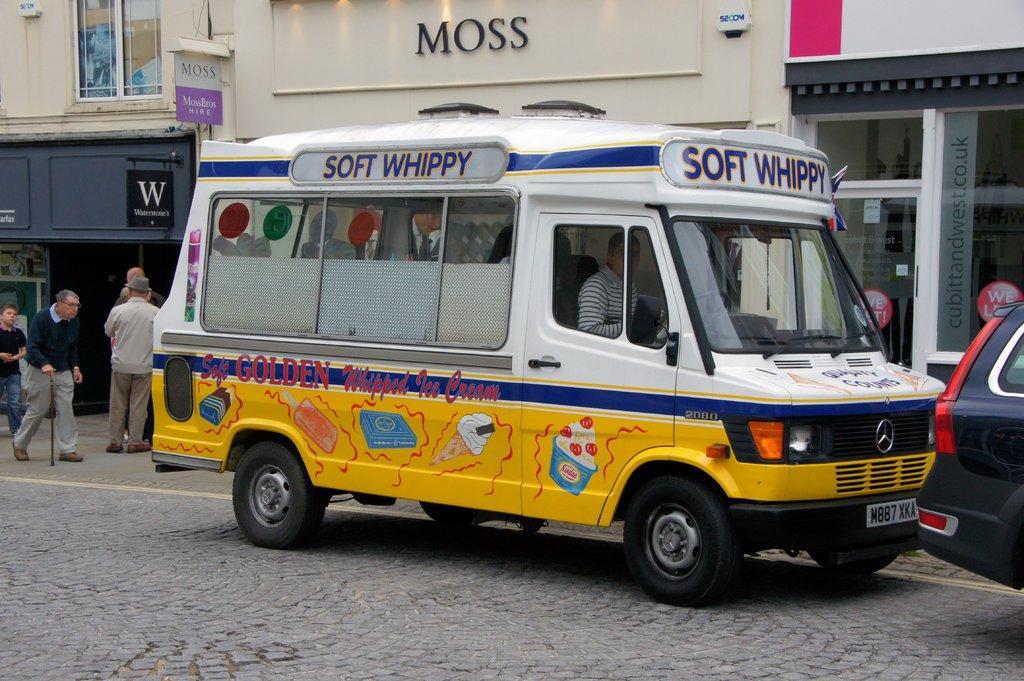Could you give a brief overview of what you see in this image? In this picture I can see there is a truck parked on the left and there is a person sitting in the truck. There is a car at right side, there are a few people standing and few are walking on the walkway. There are few buildings in the backdrop, there are name boards, windows, glass doors. 